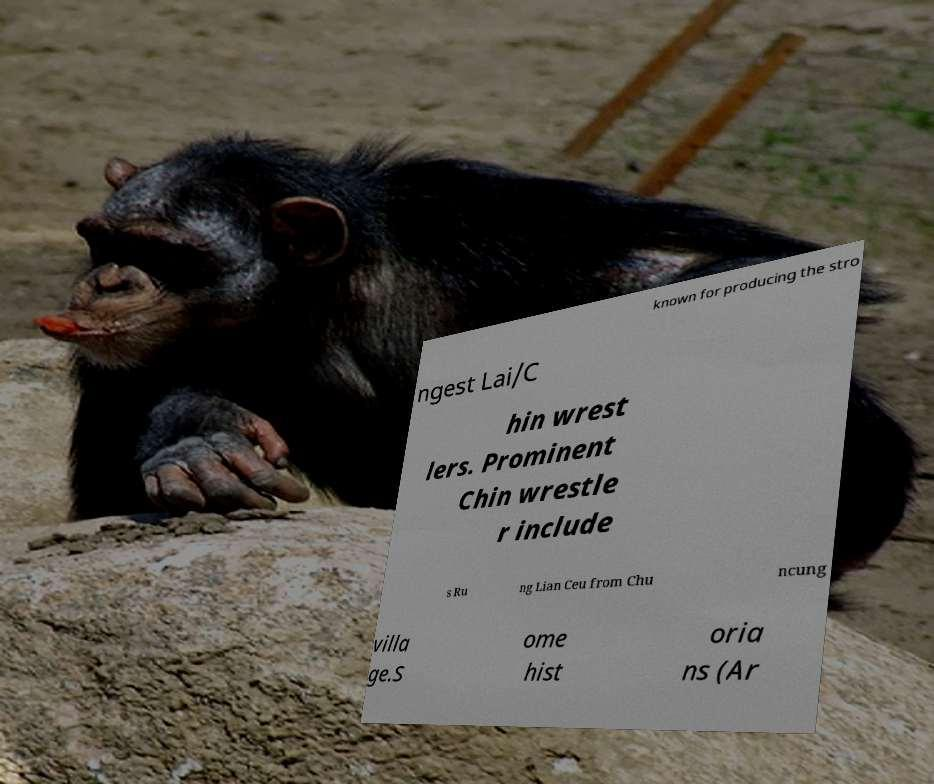Please read and relay the text visible in this image. What does it say? known for producing the stro ngest Lai/C hin wrest lers. Prominent Chin wrestle r include s Ru ng Lian Ceu from Chu ncung villa ge.S ome hist oria ns (Ar 